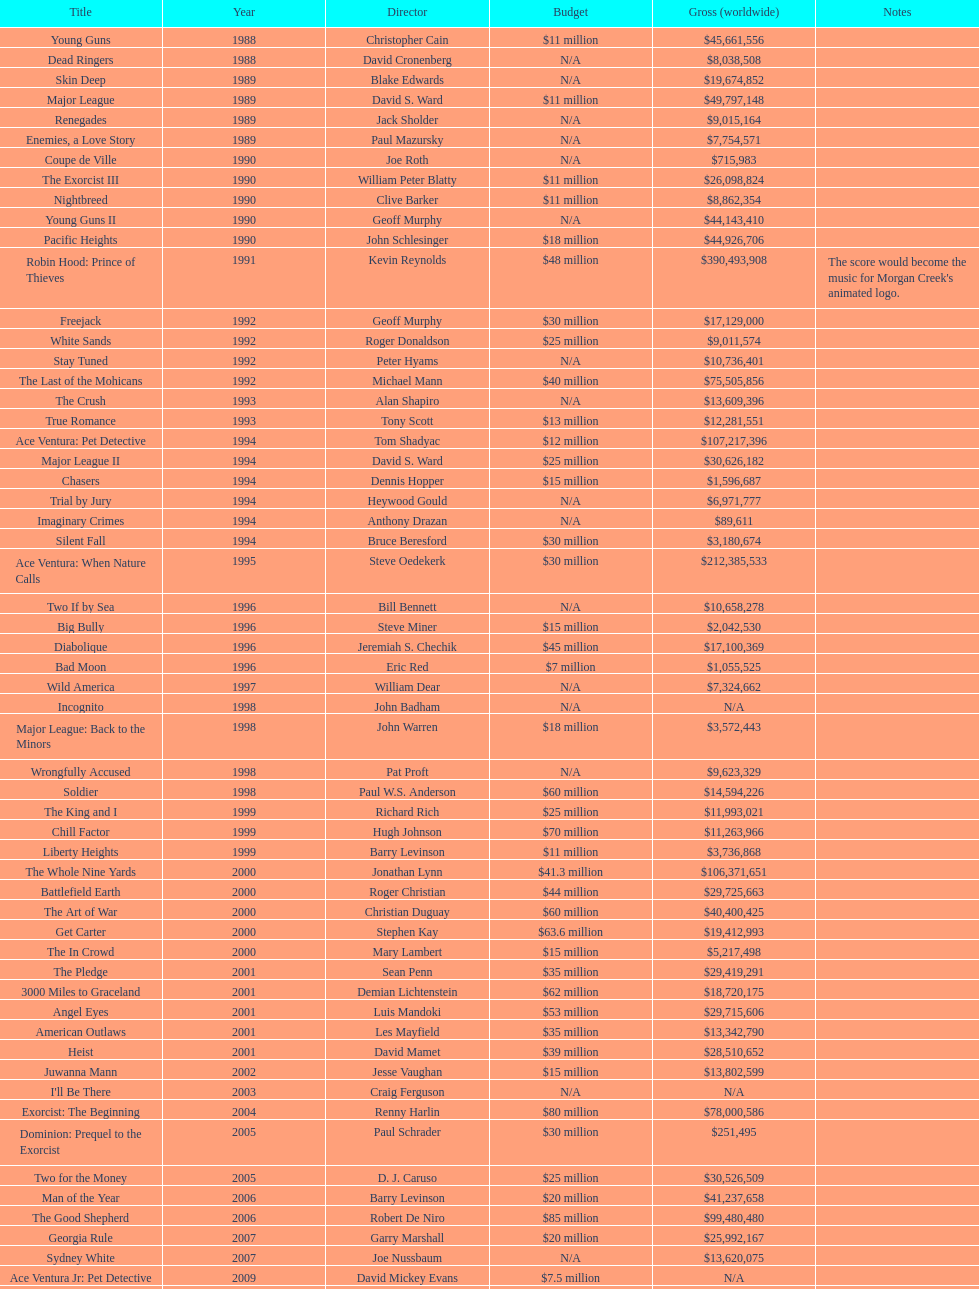Which morgan creek film grossed the most money prior to 1994? Robin Hood: Prince of Thieves. 